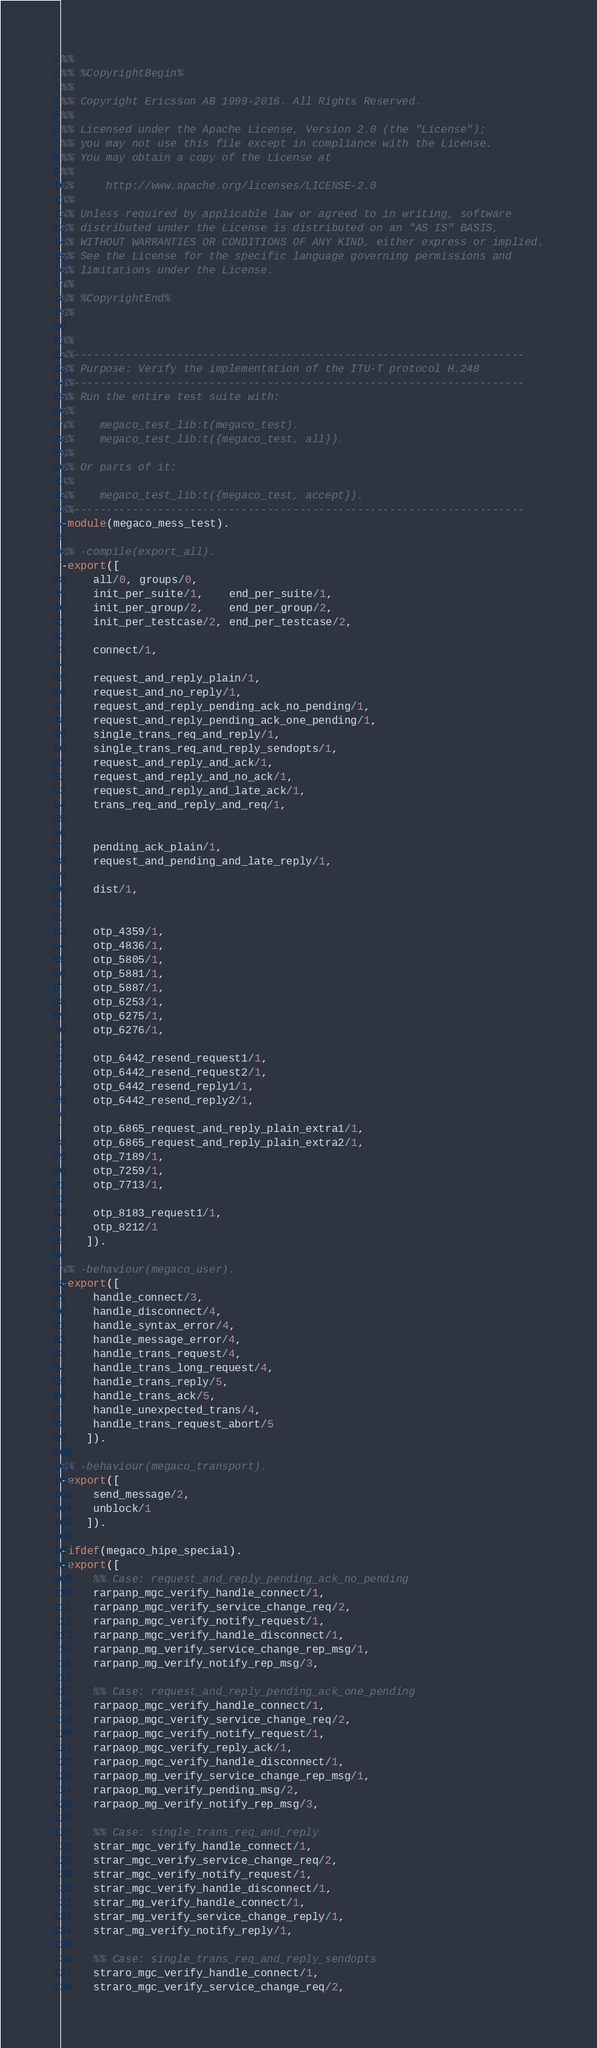Convert code to text. <code><loc_0><loc_0><loc_500><loc_500><_Erlang_>%%
%% %CopyrightBegin%
%% 
%% Copyright Ericsson AB 1999-2016. All Rights Reserved.
%% 
%% Licensed under the Apache License, Version 2.0 (the "License");
%% you may not use this file except in compliance with the License.
%% You may obtain a copy of the License at
%%
%%     http://www.apache.org/licenses/LICENSE-2.0
%%
%% Unless required by applicable law or agreed to in writing, software
%% distributed under the License is distributed on an "AS IS" BASIS,
%% WITHOUT WARRANTIES OR CONDITIONS OF ANY KIND, either express or implied.
%% See the License for the specific language governing permissions and
%% limitations under the License.
%% 
%% %CopyrightEnd%
%%

%%
%%----------------------------------------------------------------------
%% Purpose: Verify the implementation of the ITU-T protocol H.248
%%----------------------------------------------------------------------
%% Run the entire test suite with:
%% 
%%    megaco_test_lib:t(megaco_test).
%%    megaco_test_lib:t({megaco_test, all}).
%%    
%% Or parts of it:
%% 
%%    megaco_test_lib:t({megaco_test, accept}).
%%----------------------------------------------------------------------
-module(megaco_mess_test).

%% -compile(export_all).
-export([
	 all/0, groups/0, 
	 init_per_suite/1,    end_per_suite/1, 
	 init_per_group/2,    end_per_group/2, 
	 init_per_testcase/2, end_per_testcase/2,

	 connect/1,
	
	 request_and_reply_plain/1,
	 request_and_no_reply/1,
	 request_and_reply_pending_ack_no_pending/1,
	 request_and_reply_pending_ack_one_pending/1,
	 single_trans_req_and_reply/1,
	 single_trans_req_and_reply_sendopts/1,
	 request_and_reply_and_ack/1,
	 request_and_reply_and_no_ack/1,
	 request_and_reply_and_late_ack/1,
	 trans_req_and_reply_and_req/1, 
	 
	
	 pending_ack_plain/1,
	 request_and_pending_and_late_reply/1, 
	 
	 dist/1,
	 
	
	 otp_4359/1,
	 otp_4836/1,
	 otp_5805/1,
	 otp_5881/1,
	 otp_5887/1,
	 otp_6253/1,
	 otp_6275/1,
	 otp_6276/1,
	
	 otp_6442_resend_request1/1,
	 otp_6442_resend_request2/1,
	 otp_6442_resend_reply1/1,
	 otp_6442_resend_reply2/1,
	 
	 otp_6865_request_and_reply_plain_extra1/1,
	 otp_6865_request_and_reply_plain_extra2/1, 
	 otp_7189/1, 
	 otp_7259/1, 
	 otp_7713/1,
	 
	 otp_8183_request1/1, 
	 otp_8212/1
	]).

%% -behaviour(megaco_user).
-export([
	 handle_connect/3,
	 handle_disconnect/4,
	 handle_syntax_error/4,
	 handle_message_error/4,
	 handle_trans_request/4,
	 handle_trans_long_request/4,
	 handle_trans_reply/5,
	 handle_trans_ack/5,
	 handle_unexpected_trans/4,
	 handle_trans_request_abort/5
	]).

%% -behaviour(megaco_transport).
-export([
	 send_message/2,
	 unblock/1
	]).

-ifdef(megaco_hipe_special).
-export([
	 %% Case: request_and_reply_pending_ack_no_pending
	 rarpanp_mgc_verify_handle_connect/1,
	 rarpanp_mgc_verify_service_change_req/2, 
	 rarpanp_mgc_verify_notify_request/1,
	 rarpanp_mgc_verify_handle_disconnect/1,
	 rarpanp_mg_verify_service_change_rep_msg/1,
	 rarpanp_mg_verify_notify_rep_msg/3,
	 
	 %% Case: request_and_reply_pending_ack_one_pending
	 rarpaop_mgc_verify_handle_connect/1,
	 rarpaop_mgc_verify_service_change_req/2,
	 rarpaop_mgc_verify_notify_request/1,
	 rarpaop_mgc_verify_reply_ack/1,
	 rarpaop_mgc_verify_handle_disconnect/1,
	 rarpaop_mg_verify_service_change_rep_msg/1,
	 rarpaop_mg_verify_pending_msg/2,
	 rarpaop_mg_verify_notify_rep_msg/3,

	 %% Case: single_trans_req_and_reply
	 strar_mgc_verify_handle_connect/1,
	 strar_mgc_verify_service_change_req/2,
	 strar_mgc_verify_notify_request/1,
	 strar_mgc_verify_handle_disconnect/1,
	 strar_mg_verify_handle_connect/1,
	 strar_mg_verify_service_change_reply/1,
	 strar_mg_verify_notify_reply/1,

	 %% Case: single_trans_req_and_reply_sendopts
	 straro_mgc_verify_handle_connect/1,
	 straro_mgc_verify_service_change_req/2,</code> 